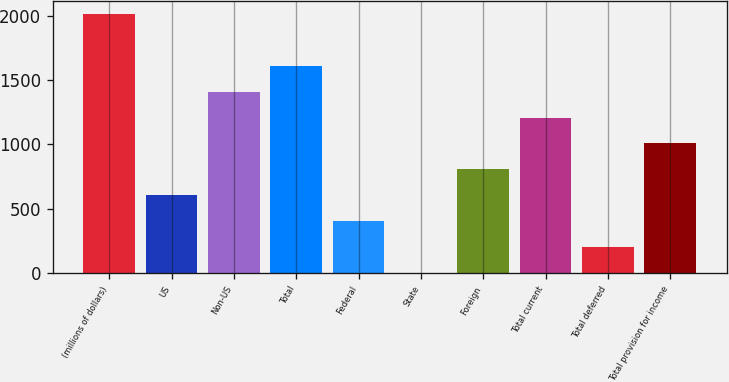<chart> <loc_0><loc_0><loc_500><loc_500><bar_chart><fcel>(millions of dollars)<fcel>US<fcel>Non-US<fcel>Total<fcel>Federal<fcel>State<fcel>Foreign<fcel>Total current<fcel>Total deferred<fcel>Total provision for income<nl><fcel>2012<fcel>605.98<fcel>1409.42<fcel>1610.28<fcel>405.12<fcel>3.4<fcel>806.84<fcel>1208.56<fcel>204.26<fcel>1007.7<nl></chart> 